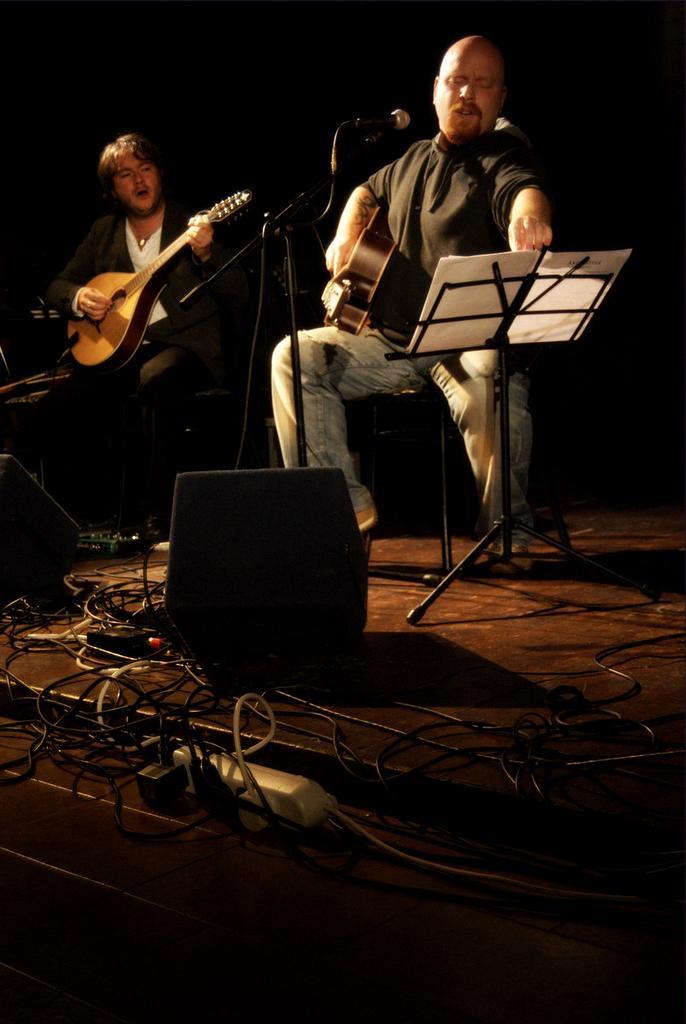Can you describe this image briefly? Two men are sitting and playing guitars on a stage. 